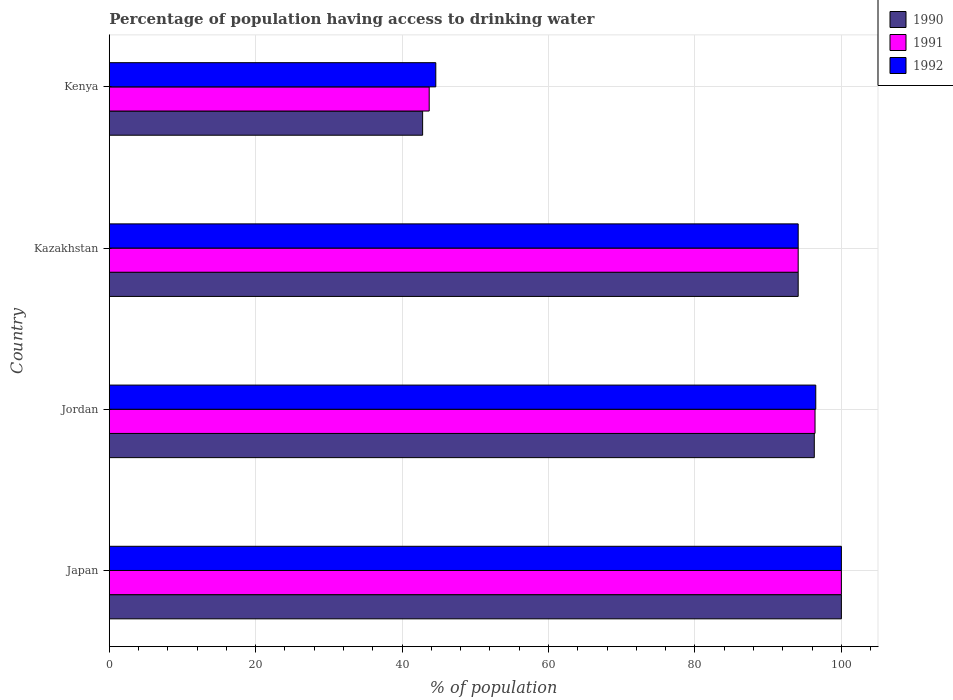How many different coloured bars are there?
Your response must be concise. 3. How many groups of bars are there?
Give a very brief answer. 4. Are the number of bars per tick equal to the number of legend labels?
Give a very brief answer. Yes. Are the number of bars on each tick of the Y-axis equal?
Your response must be concise. Yes. How many bars are there on the 2nd tick from the top?
Ensure brevity in your answer.  3. What is the label of the 2nd group of bars from the top?
Your answer should be very brief. Kazakhstan. In how many cases, is the number of bars for a given country not equal to the number of legend labels?
Offer a very short reply. 0. What is the percentage of population having access to drinking water in 1990 in Japan?
Give a very brief answer. 100. Across all countries, what is the maximum percentage of population having access to drinking water in 1992?
Give a very brief answer. 100. Across all countries, what is the minimum percentage of population having access to drinking water in 1990?
Your answer should be very brief. 42.8. In which country was the percentage of population having access to drinking water in 1991 minimum?
Keep it short and to the point. Kenya. What is the total percentage of population having access to drinking water in 1990 in the graph?
Your response must be concise. 333.2. What is the difference between the percentage of population having access to drinking water in 1990 in Japan and that in Kazakhstan?
Your response must be concise. 5.9. What is the difference between the percentage of population having access to drinking water in 1990 in Jordan and the percentage of population having access to drinking water in 1992 in Japan?
Keep it short and to the point. -3.7. What is the average percentage of population having access to drinking water in 1992 per country?
Your answer should be compact. 83.8. In how many countries, is the percentage of population having access to drinking water in 1991 greater than 60 %?
Give a very brief answer. 3. What is the ratio of the percentage of population having access to drinking water in 1992 in Japan to that in Kenya?
Your answer should be compact. 2.24. Is the percentage of population having access to drinking water in 1991 in Japan less than that in Kazakhstan?
Make the answer very short. No. Is the difference between the percentage of population having access to drinking water in 1992 in Jordan and Kenya greater than the difference between the percentage of population having access to drinking water in 1991 in Jordan and Kenya?
Your answer should be very brief. No. What is the difference between the highest and the second highest percentage of population having access to drinking water in 1990?
Ensure brevity in your answer.  3.7. What is the difference between the highest and the lowest percentage of population having access to drinking water in 1990?
Provide a short and direct response. 57.2. What does the 2nd bar from the top in Japan represents?
Your answer should be very brief. 1991. Is it the case that in every country, the sum of the percentage of population having access to drinking water in 1990 and percentage of population having access to drinking water in 1991 is greater than the percentage of population having access to drinking water in 1992?
Provide a succinct answer. Yes. What is the difference between two consecutive major ticks on the X-axis?
Ensure brevity in your answer.  20. Does the graph contain grids?
Your response must be concise. Yes. Where does the legend appear in the graph?
Make the answer very short. Top right. What is the title of the graph?
Your answer should be very brief. Percentage of population having access to drinking water. What is the label or title of the X-axis?
Make the answer very short. % of population. What is the label or title of the Y-axis?
Give a very brief answer. Country. What is the % of population in 1990 in Japan?
Make the answer very short. 100. What is the % of population of 1991 in Japan?
Your answer should be very brief. 100. What is the % of population in 1992 in Japan?
Provide a succinct answer. 100. What is the % of population of 1990 in Jordan?
Make the answer very short. 96.3. What is the % of population in 1991 in Jordan?
Your answer should be compact. 96.4. What is the % of population in 1992 in Jordan?
Your answer should be very brief. 96.5. What is the % of population in 1990 in Kazakhstan?
Keep it short and to the point. 94.1. What is the % of population in 1991 in Kazakhstan?
Offer a very short reply. 94.1. What is the % of population of 1992 in Kazakhstan?
Offer a very short reply. 94.1. What is the % of population in 1990 in Kenya?
Your answer should be very brief. 42.8. What is the % of population in 1991 in Kenya?
Make the answer very short. 43.7. What is the % of population of 1992 in Kenya?
Keep it short and to the point. 44.6. Across all countries, what is the maximum % of population of 1991?
Give a very brief answer. 100. Across all countries, what is the maximum % of population of 1992?
Keep it short and to the point. 100. Across all countries, what is the minimum % of population of 1990?
Give a very brief answer. 42.8. Across all countries, what is the minimum % of population of 1991?
Your answer should be very brief. 43.7. Across all countries, what is the minimum % of population of 1992?
Offer a very short reply. 44.6. What is the total % of population of 1990 in the graph?
Ensure brevity in your answer.  333.2. What is the total % of population of 1991 in the graph?
Provide a short and direct response. 334.2. What is the total % of population of 1992 in the graph?
Offer a very short reply. 335.2. What is the difference between the % of population of 1990 in Japan and that in Jordan?
Keep it short and to the point. 3.7. What is the difference between the % of population of 1991 in Japan and that in Jordan?
Give a very brief answer. 3.6. What is the difference between the % of population of 1992 in Japan and that in Jordan?
Your answer should be very brief. 3.5. What is the difference between the % of population in 1990 in Japan and that in Kenya?
Give a very brief answer. 57.2. What is the difference between the % of population in 1991 in Japan and that in Kenya?
Make the answer very short. 56.3. What is the difference between the % of population in 1992 in Japan and that in Kenya?
Your answer should be compact. 55.4. What is the difference between the % of population in 1991 in Jordan and that in Kazakhstan?
Ensure brevity in your answer.  2.3. What is the difference between the % of population in 1992 in Jordan and that in Kazakhstan?
Your answer should be compact. 2.4. What is the difference between the % of population in 1990 in Jordan and that in Kenya?
Offer a terse response. 53.5. What is the difference between the % of population in 1991 in Jordan and that in Kenya?
Offer a very short reply. 52.7. What is the difference between the % of population of 1992 in Jordan and that in Kenya?
Your answer should be compact. 51.9. What is the difference between the % of population of 1990 in Kazakhstan and that in Kenya?
Ensure brevity in your answer.  51.3. What is the difference between the % of population in 1991 in Kazakhstan and that in Kenya?
Keep it short and to the point. 50.4. What is the difference between the % of population of 1992 in Kazakhstan and that in Kenya?
Your answer should be very brief. 49.5. What is the difference between the % of population of 1990 in Japan and the % of population of 1991 in Jordan?
Provide a short and direct response. 3.6. What is the difference between the % of population in 1990 in Japan and the % of population in 1992 in Jordan?
Your answer should be very brief. 3.5. What is the difference between the % of population of 1991 in Japan and the % of population of 1992 in Jordan?
Your response must be concise. 3.5. What is the difference between the % of population in 1990 in Japan and the % of population in 1992 in Kazakhstan?
Offer a very short reply. 5.9. What is the difference between the % of population in 1991 in Japan and the % of population in 1992 in Kazakhstan?
Your response must be concise. 5.9. What is the difference between the % of population of 1990 in Japan and the % of population of 1991 in Kenya?
Provide a succinct answer. 56.3. What is the difference between the % of population in 1990 in Japan and the % of population in 1992 in Kenya?
Provide a succinct answer. 55.4. What is the difference between the % of population in 1991 in Japan and the % of population in 1992 in Kenya?
Your response must be concise. 55.4. What is the difference between the % of population in 1990 in Jordan and the % of population in 1991 in Kazakhstan?
Make the answer very short. 2.2. What is the difference between the % of population of 1990 in Jordan and the % of population of 1991 in Kenya?
Your response must be concise. 52.6. What is the difference between the % of population of 1990 in Jordan and the % of population of 1992 in Kenya?
Offer a very short reply. 51.7. What is the difference between the % of population in 1991 in Jordan and the % of population in 1992 in Kenya?
Your response must be concise. 51.8. What is the difference between the % of population of 1990 in Kazakhstan and the % of population of 1991 in Kenya?
Provide a short and direct response. 50.4. What is the difference between the % of population of 1990 in Kazakhstan and the % of population of 1992 in Kenya?
Offer a very short reply. 49.5. What is the difference between the % of population of 1991 in Kazakhstan and the % of population of 1992 in Kenya?
Your response must be concise. 49.5. What is the average % of population in 1990 per country?
Provide a short and direct response. 83.3. What is the average % of population in 1991 per country?
Provide a short and direct response. 83.55. What is the average % of population of 1992 per country?
Keep it short and to the point. 83.8. What is the difference between the % of population of 1990 and % of population of 1992 in Japan?
Keep it short and to the point. 0. What is the difference between the % of population of 1990 and % of population of 1992 in Jordan?
Offer a terse response. -0.2. What is the difference between the % of population of 1990 and % of population of 1992 in Kazakhstan?
Make the answer very short. 0. What is the difference between the % of population of 1990 and % of population of 1991 in Kenya?
Make the answer very short. -0.9. What is the difference between the % of population in 1990 and % of population in 1992 in Kenya?
Ensure brevity in your answer.  -1.8. What is the ratio of the % of population of 1990 in Japan to that in Jordan?
Ensure brevity in your answer.  1.04. What is the ratio of the % of population of 1991 in Japan to that in Jordan?
Keep it short and to the point. 1.04. What is the ratio of the % of population in 1992 in Japan to that in Jordan?
Your answer should be very brief. 1.04. What is the ratio of the % of population in 1990 in Japan to that in Kazakhstan?
Offer a very short reply. 1.06. What is the ratio of the % of population of 1991 in Japan to that in Kazakhstan?
Offer a terse response. 1.06. What is the ratio of the % of population of 1992 in Japan to that in Kazakhstan?
Provide a succinct answer. 1.06. What is the ratio of the % of population of 1990 in Japan to that in Kenya?
Your response must be concise. 2.34. What is the ratio of the % of population in 1991 in Japan to that in Kenya?
Ensure brevity in your answer.  2.29. What is the ratio of the % of population of 1992 in Japan to that in Kenya?
Your answer should be very brief. 2.24. What is the ratio of the % of population in 1990 in Jordan to that in Kazakhstan?
Provide a short and direct response. 1.02. What is the ratio of the % of population of 1991 in Jordan to that in Kazakhstan?
Your response must be concise. 1.02. What is the ratio of the % of population of 1992 in Jordan to that in Kazakhstan?
Your answer should be very brief. 1.03. What is the ratio of the % of population in 1990 in Jordan to that in Kenya?
Provide a short and direct response. 2.25. What is the ratio of the % of population of 1991 in Jordan to that in Kenya?
Your answer should be compact. 2.21. What is the ratio of the % of population of 1992 in Jordan to that in Kenya?
Offer a terse response. 2.16. What is the ratio of the % of population of 1990 in Kazakhstan to that in Kenya?
Make the answer very short. 2.2. What is the ratio of the % of population of 1991 in Kazakhstan to that in Kenya?
Your answer should be compact. 2.15. What is the ratio of the % of population in 1992 in Kazakhstan to that in Kenya?
Your answer should be compact. 2.11. What is the difference between the highest and the second highest % of population of 1992?
Provide a succinct answer. 3.5. What is the difference between the highest and the lowest % of population of 1990?
Offer a terse response. 57.2. What is the difference between the highest and the lowest % of population in 1991?
Provide a short and direct response. 56.3. What is the difference between the highest and the lowest % of population of 1992?
Give a very brief answer. 55.4. 